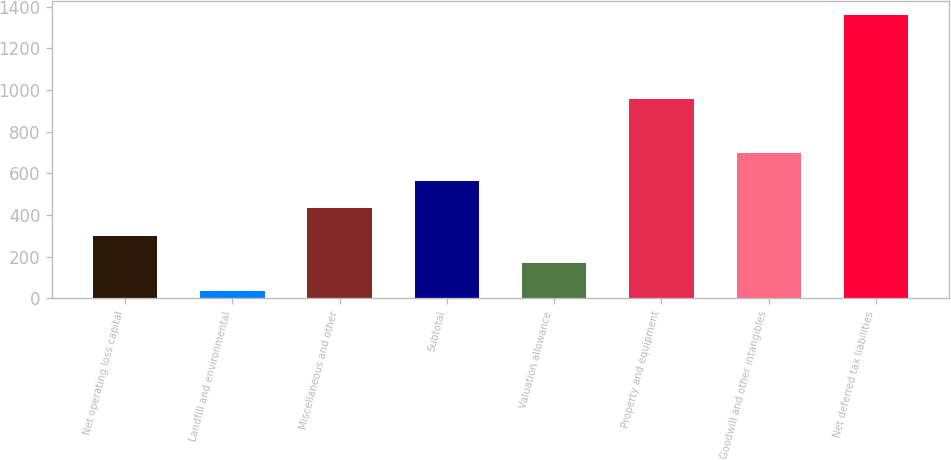Convert chart to OTSL. <chart><loc_0><loc_0><loc_500><loc_500><bar_chart><fcel>Net operating loss capital<fcel>Landfill and environmental<fcel>Miscellaneous and other<fcel>Subtotal<fcel>Valuation allowance<fcel>Property and equipment<fcel>Goodwill and other intangibles<fcel>Net deferred tax liabilities<nl><fcel>300.5<fcel>35<fcel>433<fcel>565.5<fcel>168<fcel>957<fcel>698<fcel>1360<nl></chart> 